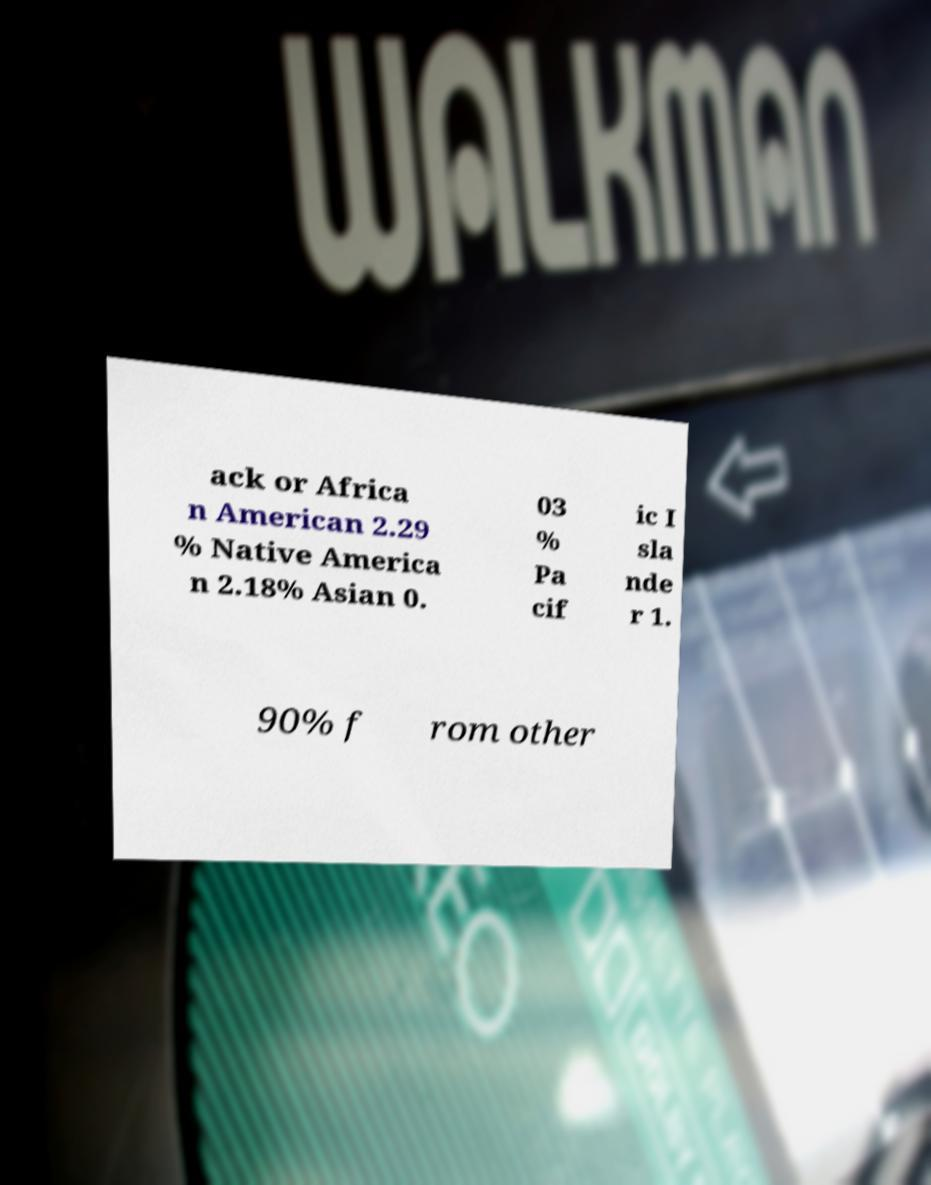Could you assist in decoding the text presented in this image and type it out clearly? ack or Africa n American 2.29 % Native America n 2.18% Asian 0. 03 % Pa cif ic I sla nde r 1. 90% f rom other 